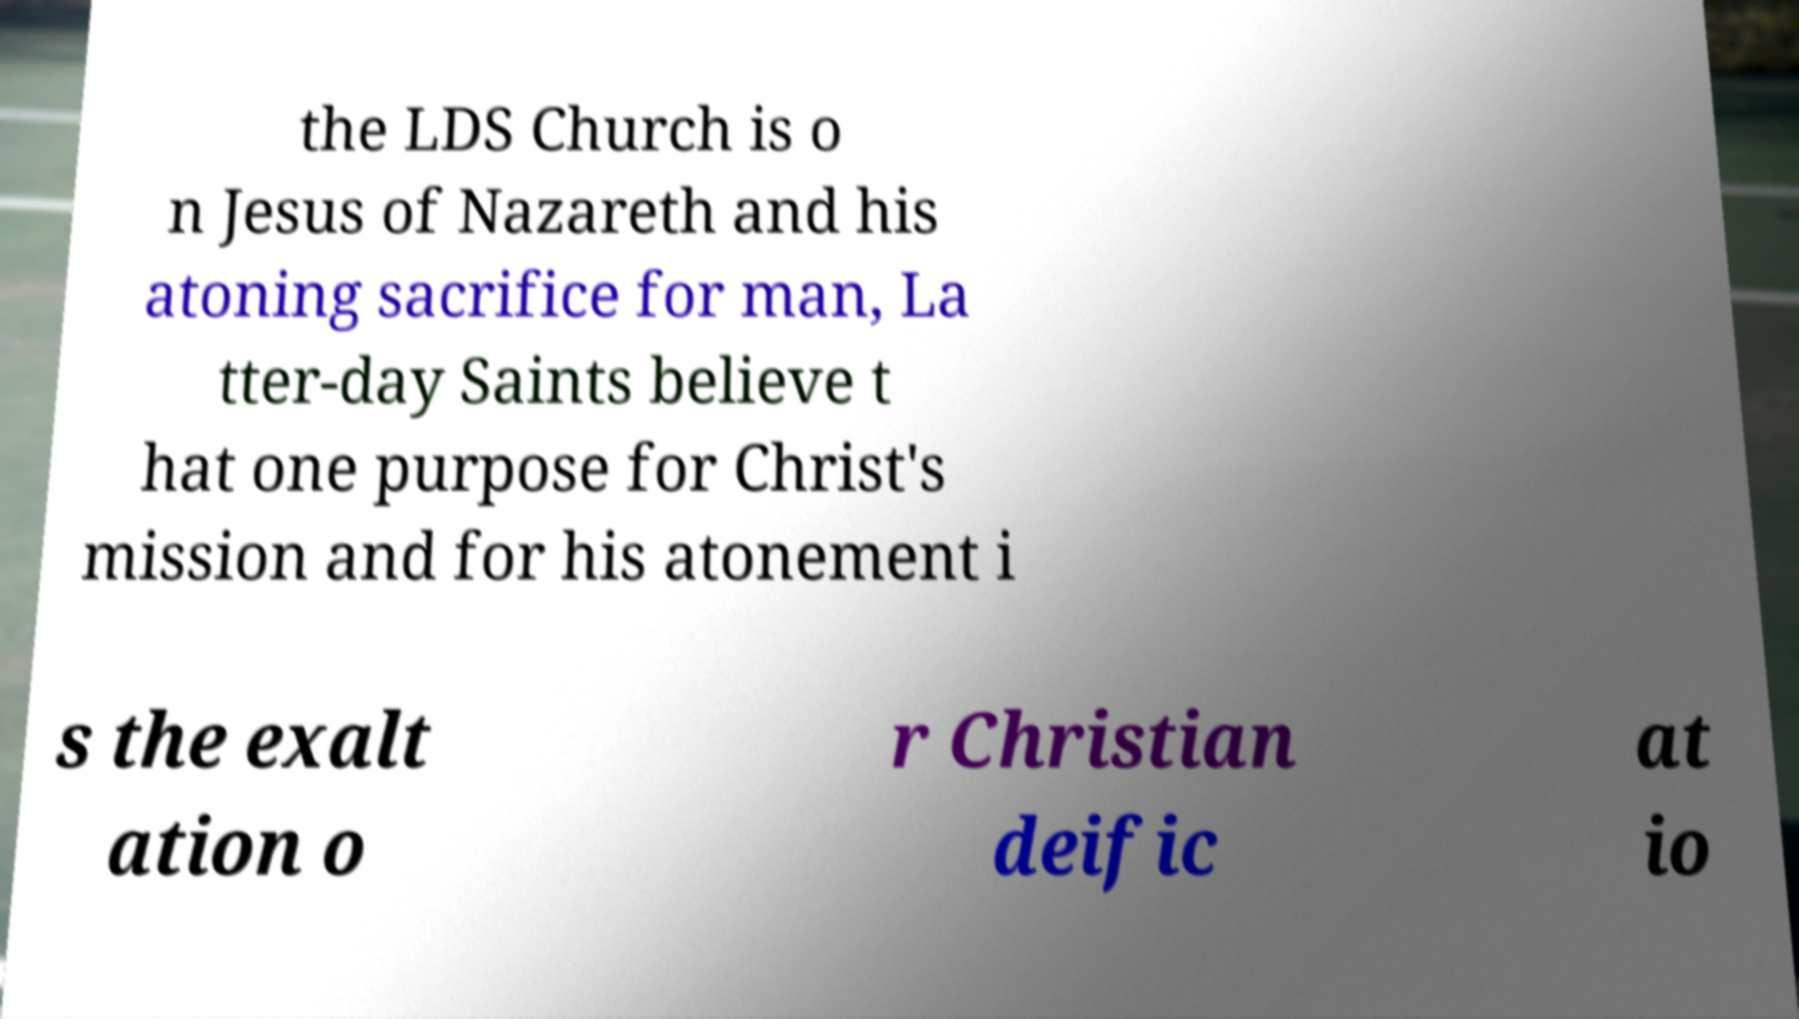Could you assist in decoding the text presented in this image and type it out clearly? the LDS Church is o n Jesus of Nazareth and his atoning sacrifice for man, La tter-day Saints believe t hat one purpose for Christ's mission and for his atonement i s the exalt ation o r Christian deific at io 